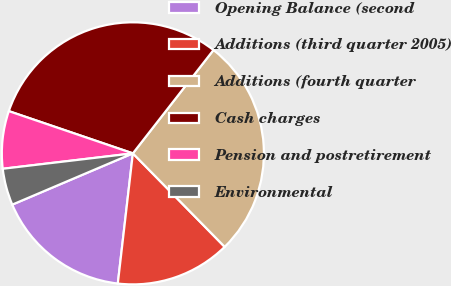<chart> <loc_0><loc_0><loc_500><loc_500><pie_chart><fcel>Opening Balance (second<fcel>Additions (third quarter 2005)<fcel>Additions (fourth quarter<fcel>Cash charges<fcel>Pension and postretirement<fcel>Environmental<nl><fcel>16.77%<fcel>14.19%<fcel>27.1%<fcel>30.32%<fcel>7.1%<fcel>4.52%<nl></chart> 